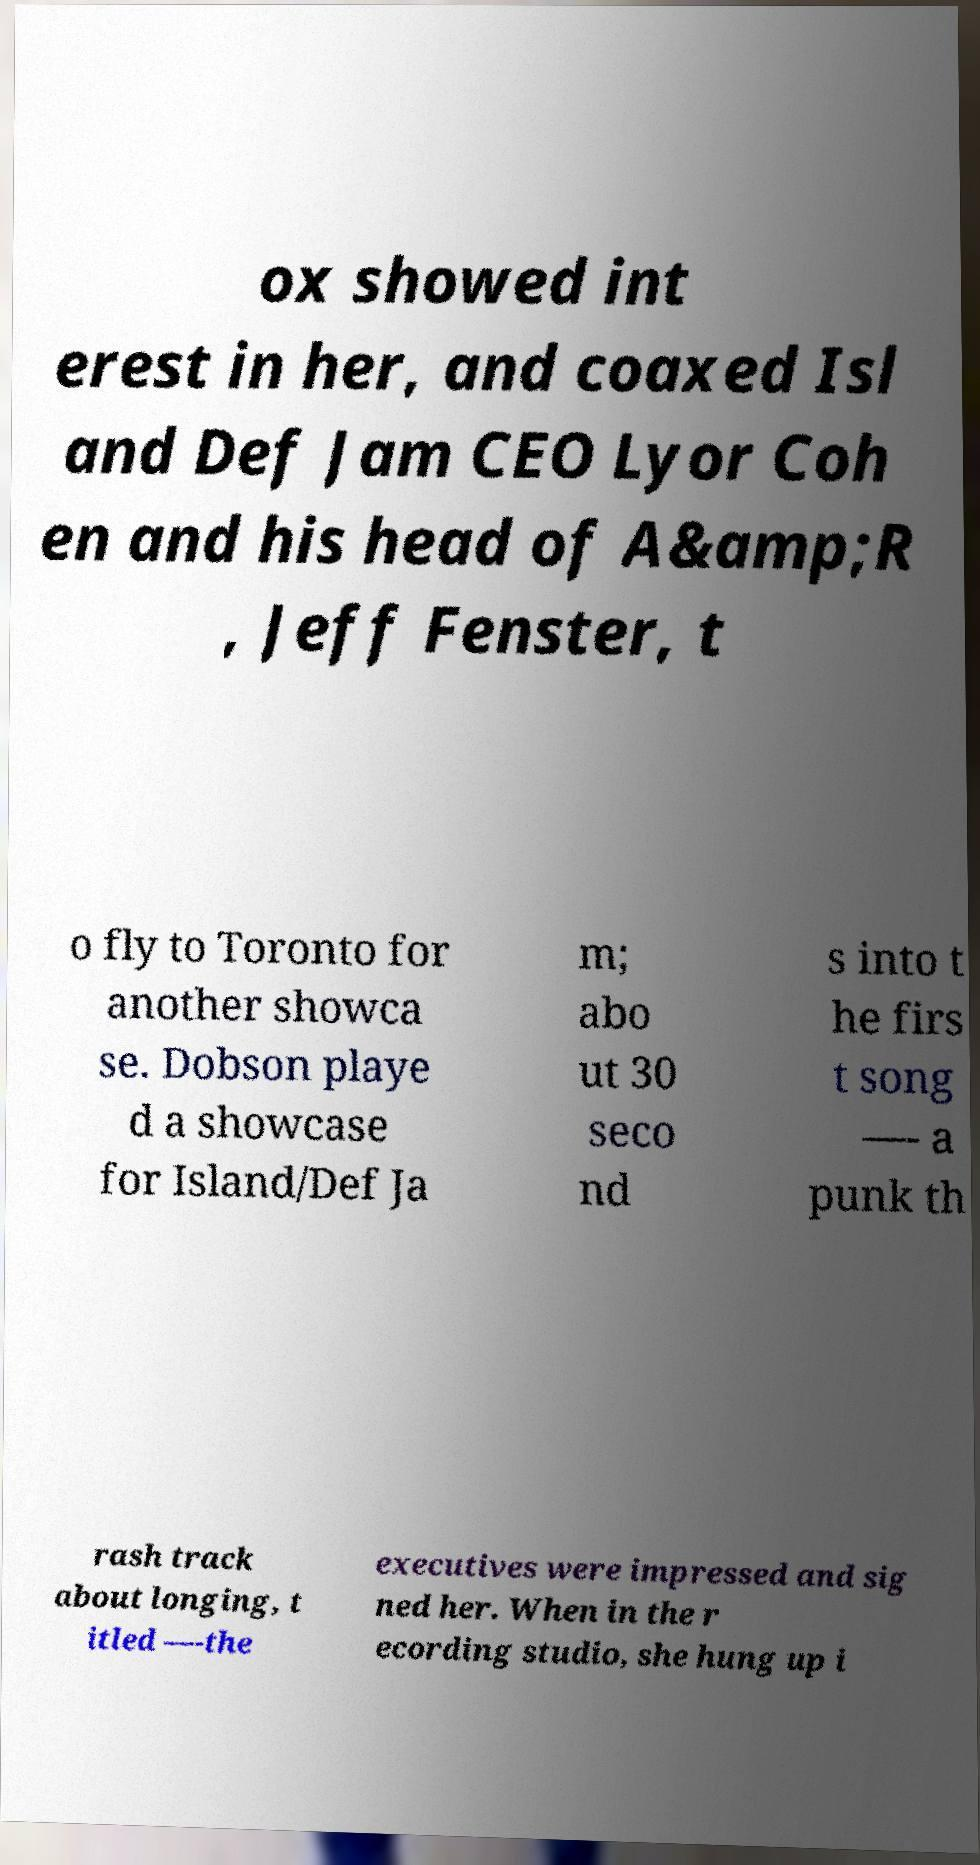What messages or text are displayed in this image? I need them in a readable, typed format. ox showed int erest in her, and coaxed Isl and Def Jam CEO Lyor Coh en and his head of A&amp;R , Jeff Fenster, t o fly to Toronto for another showca se. Dobson playe d a showcase for Island/Def Ja m; abo ut 30 seco nd s into t he firs t song —- a punk th rash track about longing, t itled —-the executives were impressed and sig ned her. When in the r ecording studio, she hung up i 